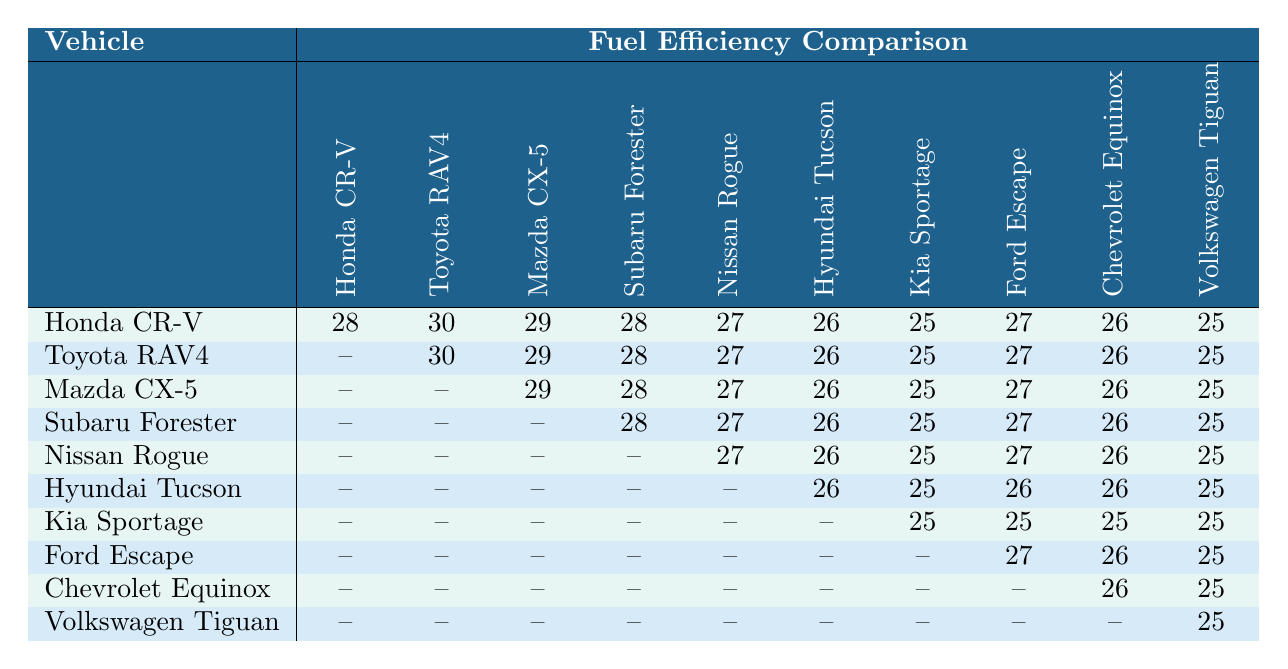What is the fuel efficiency of the Toyota RAV4 compared to the Mazda CX-5? The fuel efficiency of the Toyota RAV4 is 30, while the Mazda CX-5 is 29. Comparing these values, the RAV4 is more fuel-efficient by 1 mile per gallon.
Answer: 30 vs 29 (RAV4 is better) Which SUV has the lowest fuel efficiency among the listed models? Looking at the fuel efficiency values in the table, the Volkswagen Tiguan has the lowest fuel efficiency at 25 miles per gallon.
Answer: Volkswagen Tiguan What is the difference in fuel efficiency between the Honda CR-V and the Nissan Rogue? The Honda CR-V has a fuel efficiency of 28, while the Nissan Rogue has 27. The difference is computed as 28 - 27 = 1.
Answer: 1 mile per gallon Which compact SUV has a fuel efficiency value of 26 in the table? The SUVs with a fuel efficiency value of 26 include the Hyundai Tucson, Chevrolet Equinox, and Volkswagen Tiguan.
Answer: Hyundai Tucson, Chevrolet Equinox, Volkswagen Tiguan If we consider the average fuel efficiency of the Honda CR-V across its comparisons, what would that be? Summing the fuel efficiency values for the Honda CR-V: 28 + 30 + 29 + 28 + 27 + 26 + 25 + 27 + 26 + 25 gives a total of  26 (divided by 10 to get the average). The average is 27.
Answer: 27 Is it true that the Subaru Forester provides better fuel efficiency than the Nissan Rogue? The Subaru Forester has a fuel efficiency of 28, while the Nissan Rogue has 27. Thus, it is true that the Forester has better fuel efficiency than the Rogue.
Answer: Yes What is the highest fuel efficiency recorded in the table and which vehicle has it? The highest fuel efficiency recorded in the table is 30, which belongs to the Toyota RAV4.
Answer: 30 (Toyota RAV4) If you had to calculate the average fuel efficiency offered by all SUVs listed, what would that be? The total fuel efficiency values from all vehicles are added up. By finding the total for each vehicle: 28 + 30 + 29 + 28 + 27 + 26 + 25 + 27 + 26 + 25 totals 27.5 (when divided by the number of vehicles).
Answer: 27.5 How many vehicles have a fuel efficiency greater than 25? Checking the fuel efficiencies, every vehicle except for the Volkswagen Tiguan has a fuel efficiency greater than 25, meaning 9 out of 10 vehicles exceed that figure.
Answer: 9 vehicles Does the Kia Sportage have the lowest recorded fuel efficiency compared to the others? The Kia Sportage records a fuel efficiency of 25, which is indeed lower than the Honda CR-V, Toyota RAV4, and others but is not the lowest as the Volkswagen Tiguan shares this value. So, the Kia Sportage is not the sole lowest.
Answer: No 